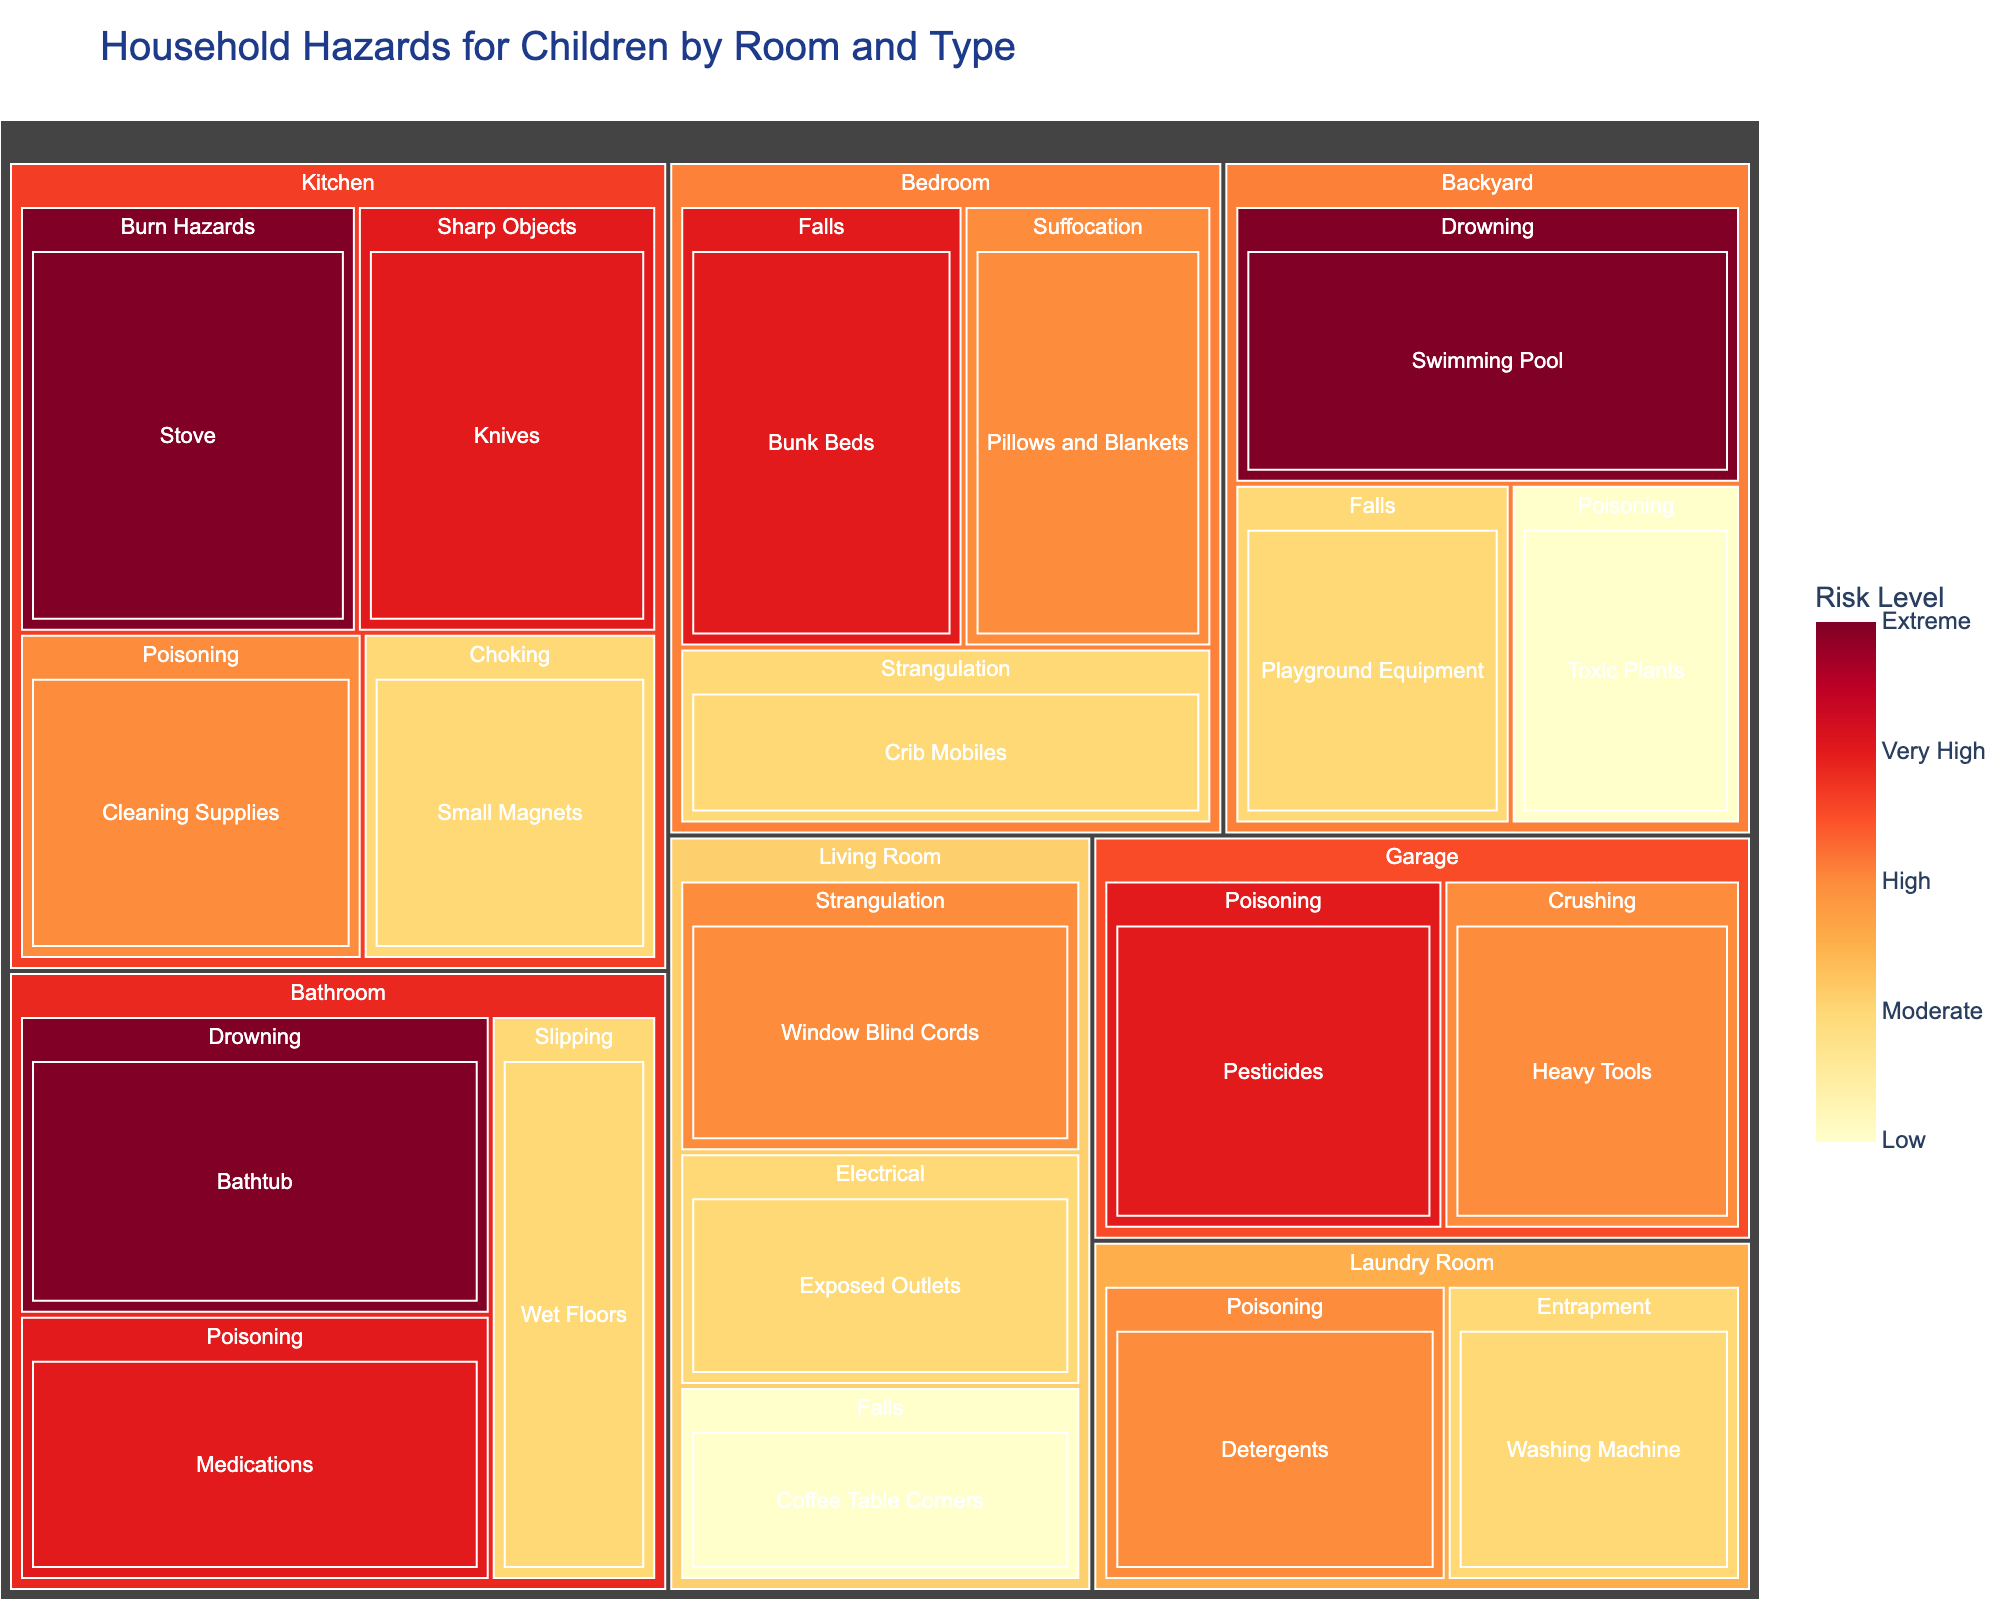What is the title of the treemap? The title of any figure usually appears at the top and it gives a clear idea of what the visual represents. In this treemap, the title is easily identifiable at the top of the figure.
Answer: Household Hazards for Children by Room and Type Which room has the highest risk level hazard? To find this, look at the color intensity and size of the tiles. The highest risk level has the most intense color in the 'YlOrRd' scale.
Answer: Kitchen What is the specific hazard with the highest risk level in the bathroom? First, locate the bathroom section in the treemap. Then, identify the specific hazard that has the most intense color and highest value.
Answer: Bathtub How many types of hazards are listed for the backyard? Locate the backyard section and count the distinct hazard categories displayed within that section.
Answer: 3 Which room has more high-risk hazards: the living room or the bedroom? Compare the number of boxes in the living room and bedroom that have a high-risk level (approaching 7 or above in color intensity).
Answer: Bedroom What is the risk level of small magnets in the kitchen? Navigate to the kitchen section, then find the specific hazard labeled as small magnets. Observe the associated risk level.
Answer: 6 What are the risk levels for drowning hazards across all rooms? Identify all tiles categorized under 'Drowning', and list out their respective risk levels while noting the rooms.
Answer: Bathroom: 9, Backyard: 9 Which room has the most diverse types of hazards listed? Count the number of distinct hazard categories within each room section and identify the room with the most.
Answer: Kitchen What is the average risk level of hazards in the bathroom? Add up the risk levels of all hazards listed under the bathroom and divide by the total number of hazards to find the average.
Answer: (9 + 8 + 6)/3 = 23/3 ≈ 7.67 Are there any moderate-risk (risk level 6) hazards in the bedroom? Find the bedroom section and look for any tiles with a risk level of 6.
Answer: Yes 